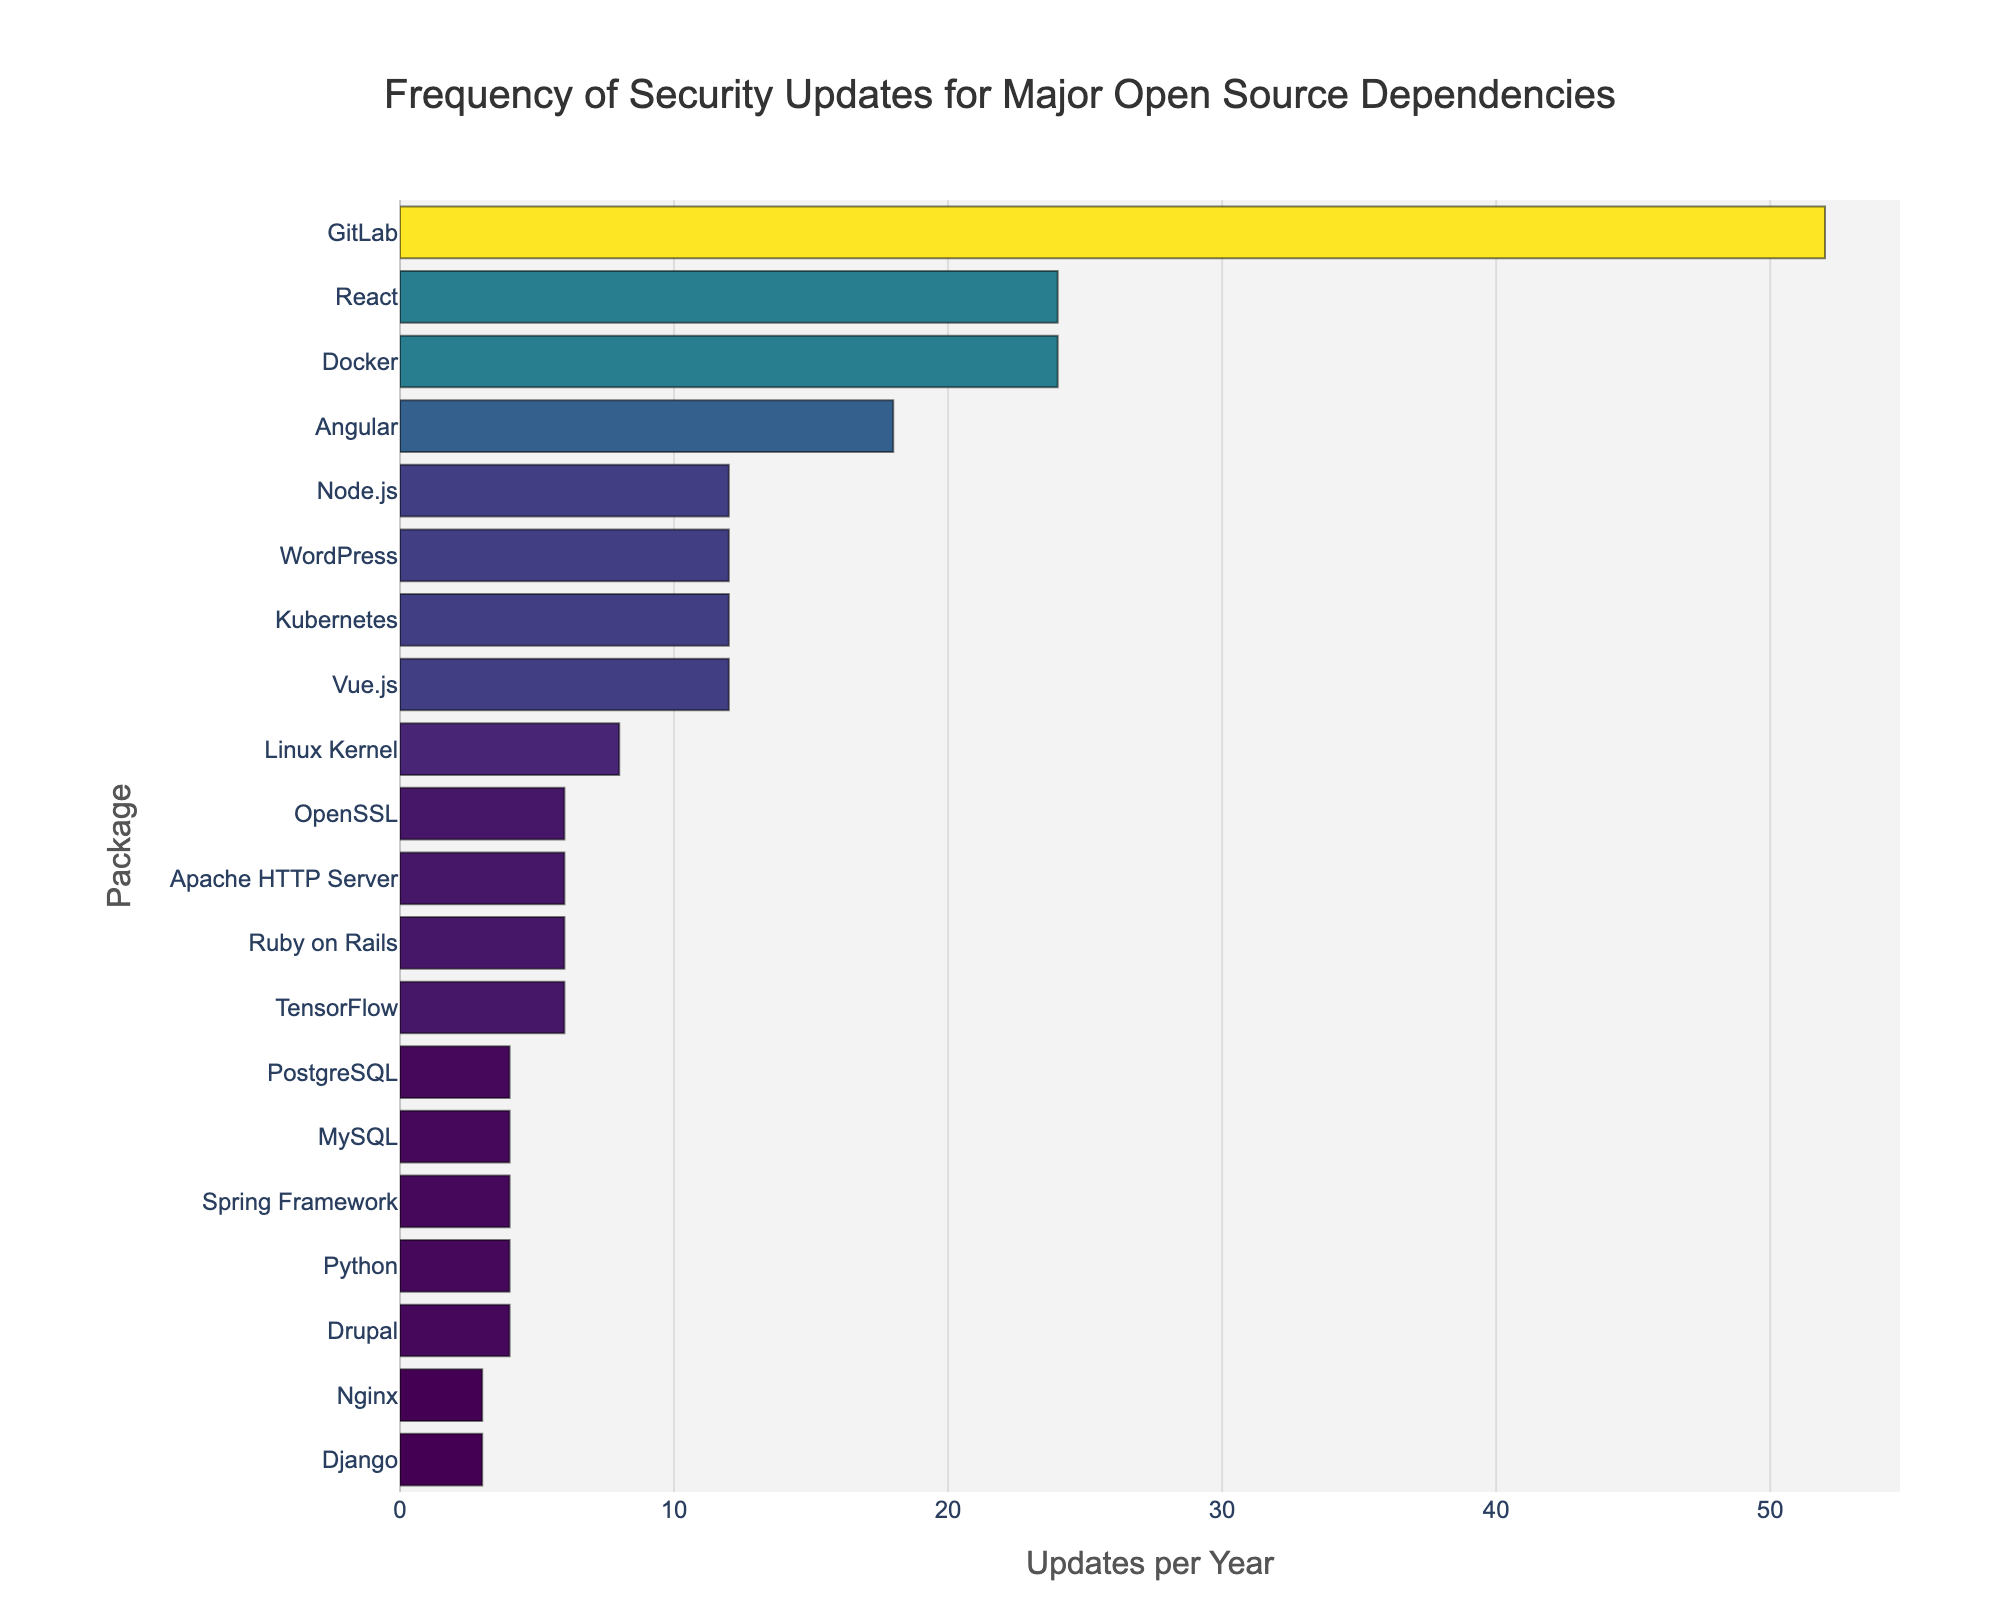What's the package with the highest frequency of security updates? The package with the highest frequency of security updates is represented by the longest bar in the chart. By identifying which package bars extend the farthest to the right, we can find the package with the highest updates per year. In this case, it is GitLab.
Answer: GitLab Which packages receive fewer updates per year than Kubernetes? To answer this, we first locate Kubernetes on the y-axis, which corresponds to an update frequency of 12 per year. Then, by visually comparing the length of bars to the left, we identify the packages that have bars shorter than 12 updates. These packages are: Python (4), MySQL (4), PostgreSQL (4), Nginx (3), Django (3), Drupal (4), Spring Framework (4).
Answer: Python, MySQL, PostgreSQL, Nginx, Django, Drupal, Spring Framework What is the difference in update frequency per year between Docker and TensorFlow? Docker has an update frequency of 24 per year, while TensorFlow has 6. The difference can be calculated by subtracting 6 from 24.
Answer: 18 Which package has the same update frequency as Node.js? Looking at the bar lengths, Node.js has an update frequency of 12. We then check for other packages with a 12 updates per year bar length. These packages are Kubernetes and Vue.js.
Answer: Kubernetes, Vue.js How many packages receive 6 or more updates per year? We count the number of bars that extend to or beyond the 6 updates per year mark. These packages are Linux Kernel (8), OpenSSL (6), Node.js (12), Docker (24), Kubernetes (12), Apache HTTP Server (6), TensorFlow (6), React (24), Angular (18), Ruby on Rails (6), WordPress (12), GitLab (52).
Answer: 12 What is the combined update frequency per year for Angular, React, and Vue.js? Angular has 18 updates per year, React has 24, and Vue.js has 12. Adding these together gives us 18 + 24 + 12.
Answer: 54 Is there any package that has an equal number of updates per year to both MySQL and PostgreSQL? MySQL and PostgreSQL both have 4 updates per year. By checking the chart, we find that Python, Drupal, and Spring Framework also have 4 updates per year.
Answer: Python, Drupal, Spring Framework 